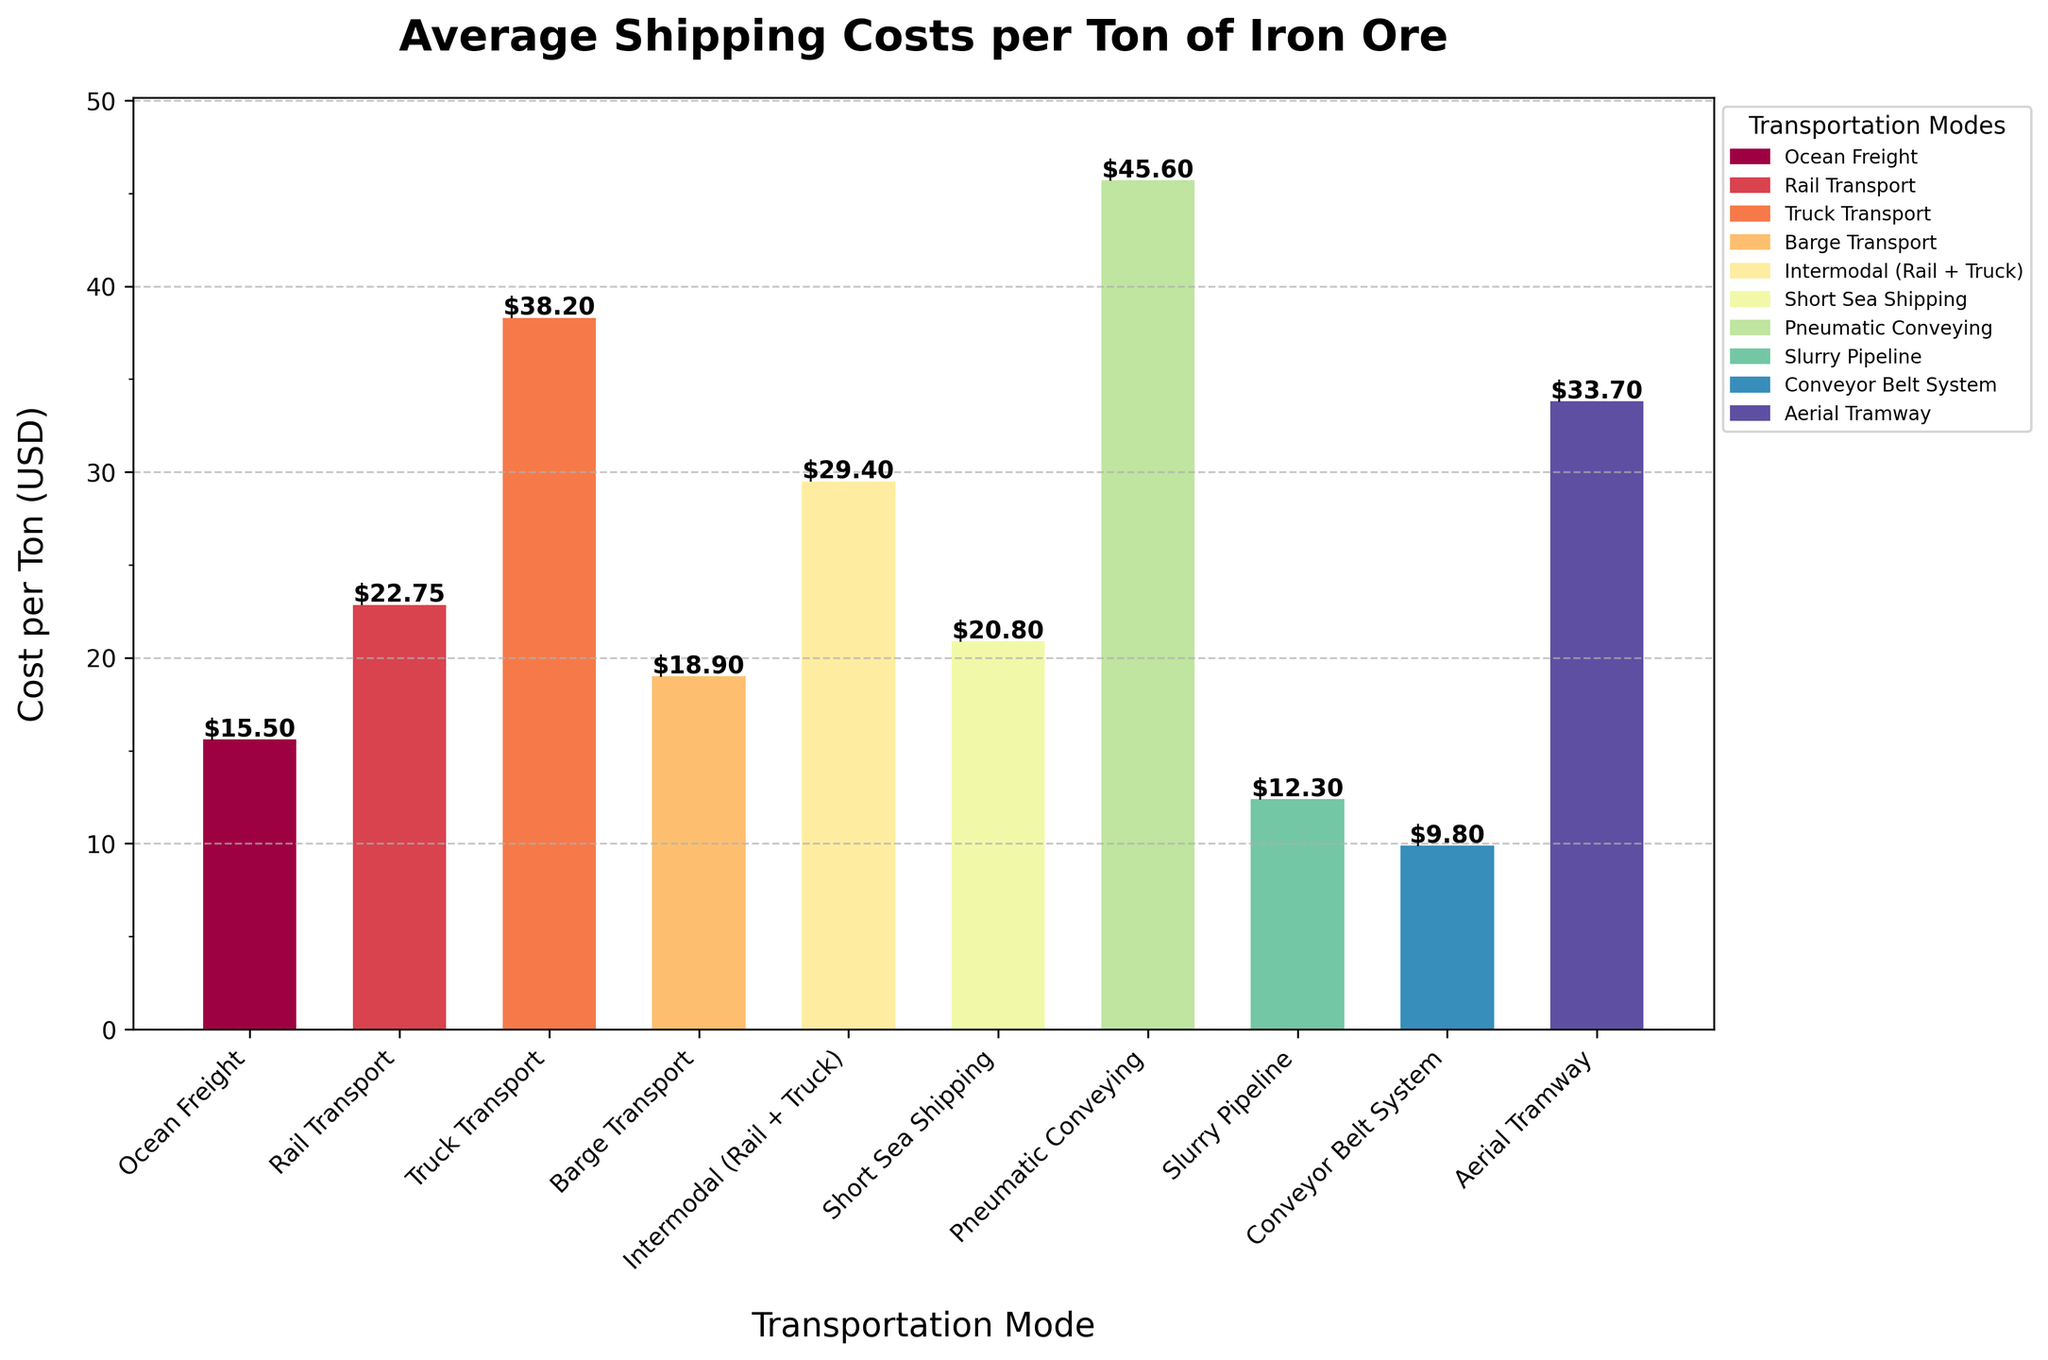What's the most expensive transportation mode? Identify the highest bar on the chart. The tallest bar represents Pneumatic Conveying.
Answer: Pneumatic Conveying Which transportation mode costs the least per ton? Look for the shortest bar on the chart. The shortest bar represents Conveyor Belt System.
Answer: Conveyor Belt System What are the total costs if iron ore is shipped equally using Ocean Freight and Truck Transport? Sum the costs of Ocean Freight and Truck Transport. $15.50 + $38.20 = $53.70
Answer: $53.70 How much more does Truck Transport cost compared to Rail Transport per ton? Subtract the cost of Rail Transport from the cost of Truck Transport. $38.20 - $22.75 = $15.45
Answer: $15.45 Which two transportation modes have the closest shipping costs per ton? Identify bars with similar heights by visual inspection. Barge Transport ($18.90) and Short Sea Shipping ($20.80) are close in cost. The difference is $1.90, compared to others.
Answer: Barge Transport and Short Sea Shipping What's the average cost per ton of all transportation modes? Sum all costs and divide by the number of modes. Total = ($15.50 + $22.75 + $38.20 + $18.90 + $29.40 + $20.80 + $45.60 + $12.30 + $9.80 + $33.70) = $247.95, average = $247.95 / 10 = $24.80
Answer: $24.80 Which modes have a cost per ton below $20? Identify bars that are below the $20 mark on the y-axis. They are Ocean Freight, Barge Transport, Slurry Pipeline, and Conveyor Belt System.
Answer: Ocean Freight, Barge Transport, Slurry Pipeline, Conveyor Belt System What is the median cost per ton of these transportation modes? List and sort all costs: $9.80, $12.30, $15.50, $18.90, $20.80, $22.75, $29.40, $33.70, $38.20, $45.60. The median is the average of the 5th and 6th values: ($20.80 + $22.75) / 2 = $21.775
Answer: $21.775 How much more expensive is the most costly mode compared to the least costly mode? Subtract the cost of the least costly mode (Conveyor Belt System) from the most costly mode (Pneumatic Conveying). $45.60 - $9.80 = $35.80
Answer: $35.80 